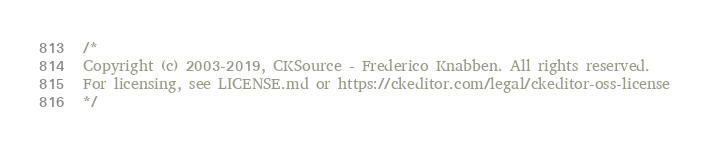<code> <loc_0><loc_0><loc_500><loc_500><_CSS_>/*
Copyright (c) 2003-2019, CKSource - Frederico Knabben. All rights reserved.
For licensing, see LICENSE.md or https://ckeditor.com/legal/ckeditor-oss-license
*/</code> 